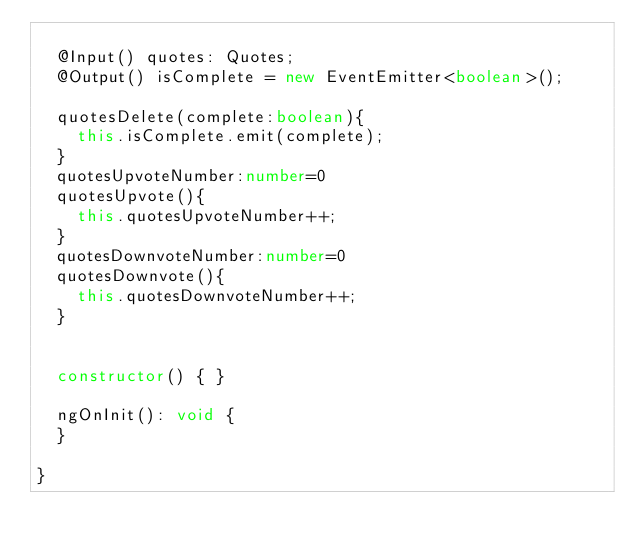<code> <loc_0><loc_0><loc_500><loc_500><_TypeScript_>
  @Input() quotes: Quotes;
  @Output() isComplete = new EventEmitter<boolean>();

  quotesDelete(complete:boolean){
    this.isComplete.emit(complete);
  }
  quotesUpvoteNumber:number=0
  quotesUpvote(){
    this.quotesUpvoteNumber++;
  }
  quotesDownvoteNumber:number=0
  quotesDownvote(){
    this.quotesDownvoteNumber++;
  }

  
  constructor() { }

  ngOnInit(): void {
  }

}
</code> 